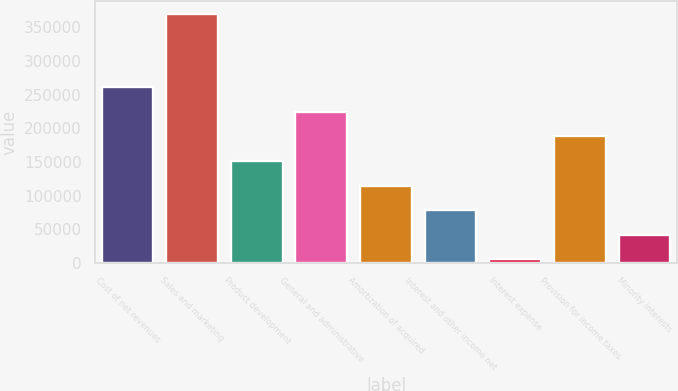Convert chart to OTSL. <chart><loc_0><loc_0><loc_500><loc_500><bar_chart><fcel>Cost of net revenues<fcel>Sales and marketing<fcel>Product development<fcel>General and administrative<fcel>Amortization of acquired<fcel>Interest and other income net<fcel>Interest expense<fcel>Provision for income taxes<fcel>Minority interests<nl><fcel>260946<fcel>370465<fcel>151427<fcel>224439<fcel>114920<fcel>78413.8<fcel>5401<fcel>187933<fcel>41907.4<nl></chart> 